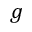<formula> <loc_0><loc_0><loc_500><loc_500>g</formula> 